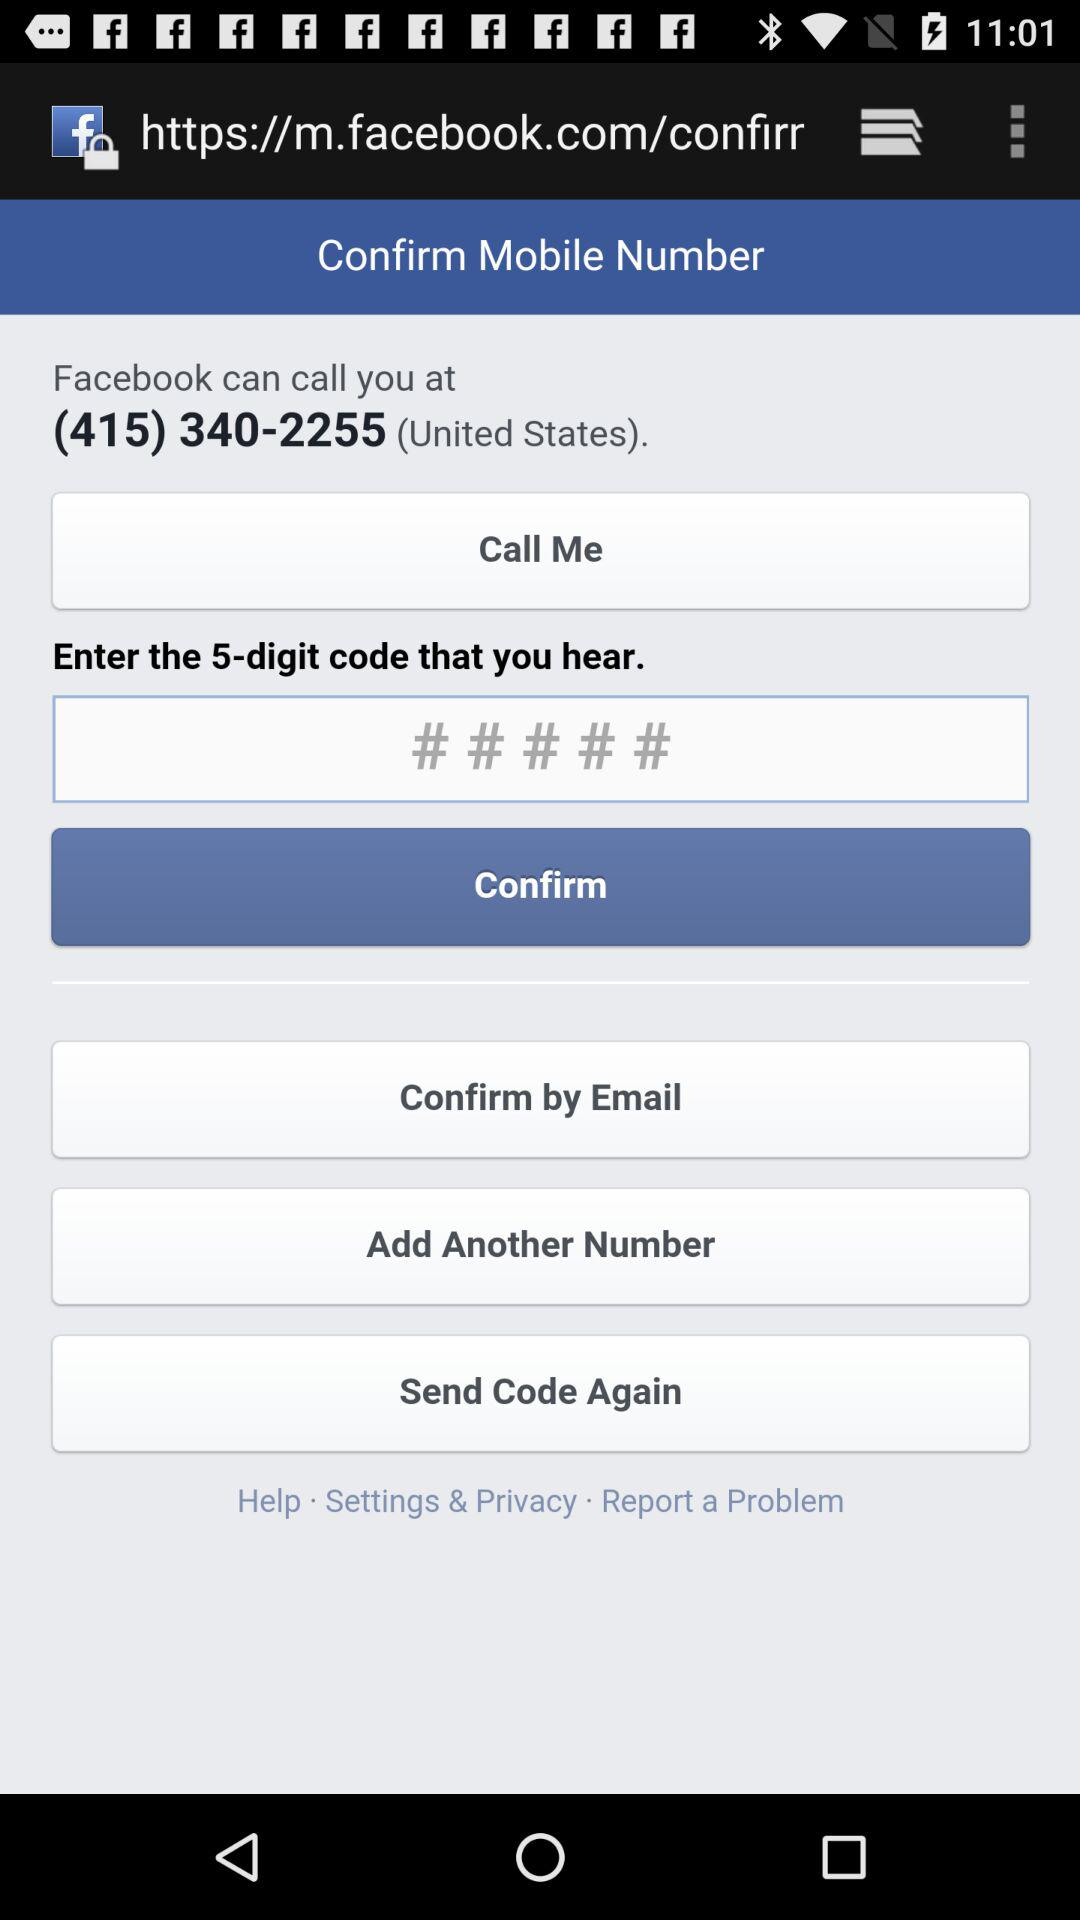What is the contact number? The contact number is (415) 340-2255. 